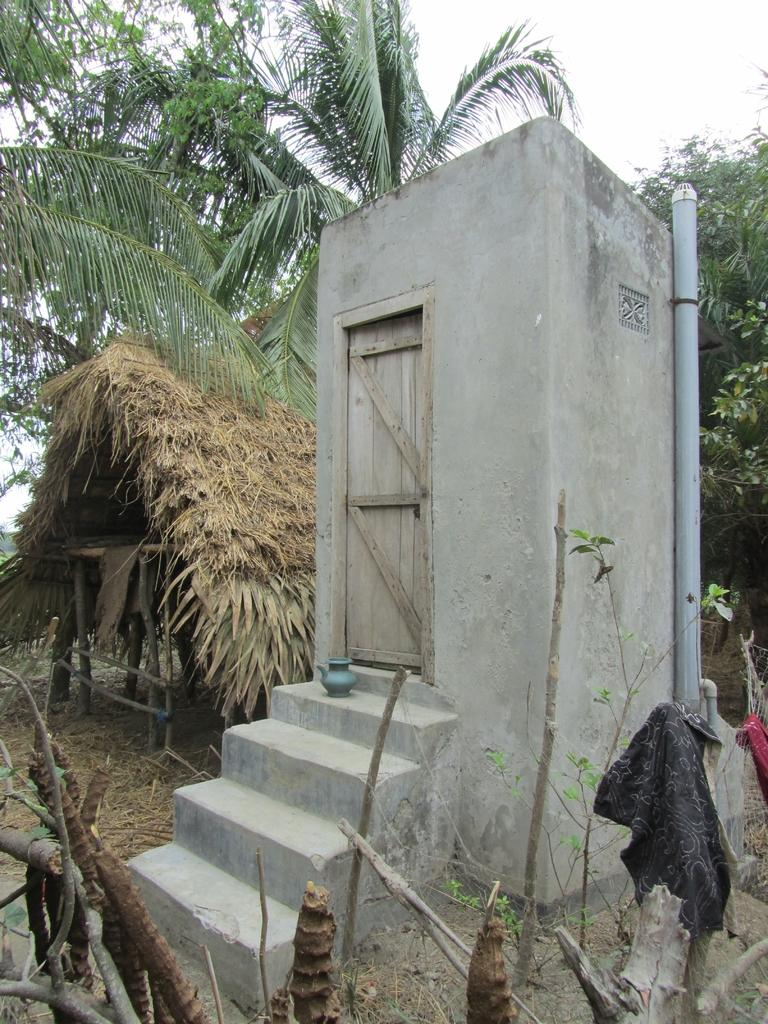What type of natural vegetation can be seen in the image? There are trees in the image. What architectural feature is present in the image? There are steps in the image. What is attached to a room in the image? There is a pipe attached to a room in the image. What can be seen in the background of the image? Trees, the sky, and a hut are visible in the background of the image. Are there any other objects visible in the background of the image? Yes, there are other objects visible in the background of the image. What type of noise can be heard coming from the library in the image? There is no library present in the image, so it is not possible to determine what, if any, noise might be heard. What is the hook used for in the image? There is no hook present in the image. 